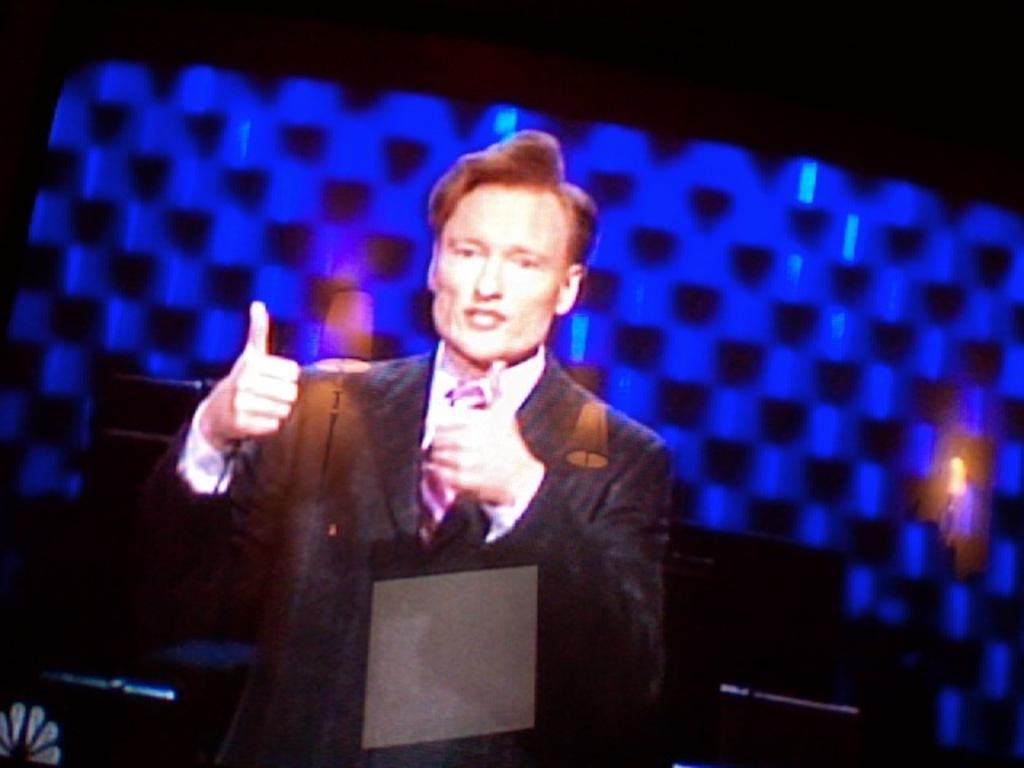Can you describe this image briefly? In this image, we can see a man standing and he is wearing a coat and a tie, there is a blue background. 